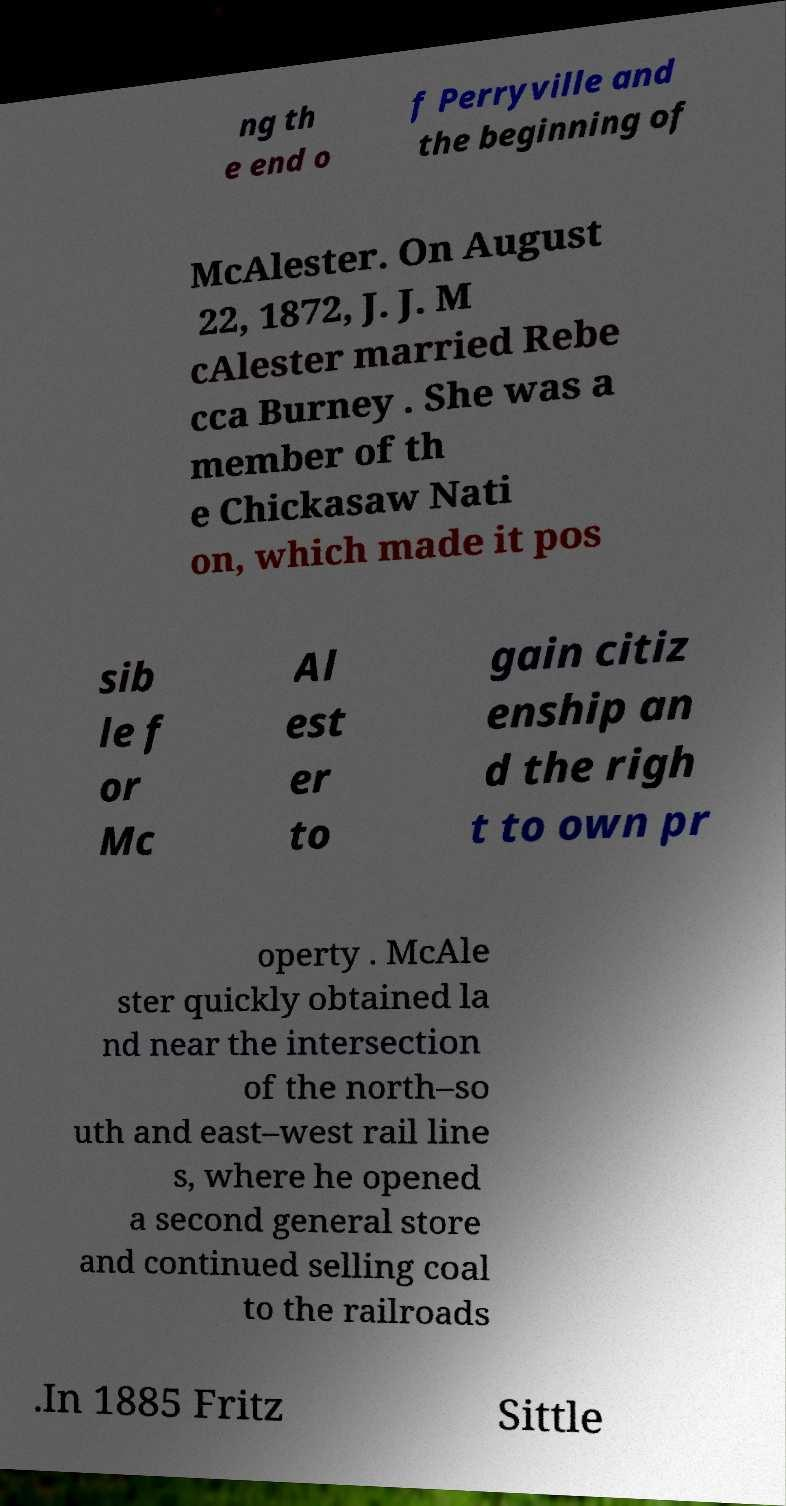Could you extract and type out the text from this image? ng th e end o f Perryville and the beginning of McAlester. On August 22, 1872, J. J. M cAlester married Rebe cca Burney . She was a member of th e Chickasaw Nati on, which made it pos sib le f or Mc Al est er to gain citiz enship an d the righ t to own pr operty . McAle ster quickly obtained la nd near the intersection of the north–so uth and east–west rail line s, where he opened a second general store and continued selling coal to the railroads .In 1885 Fritz Sittle 